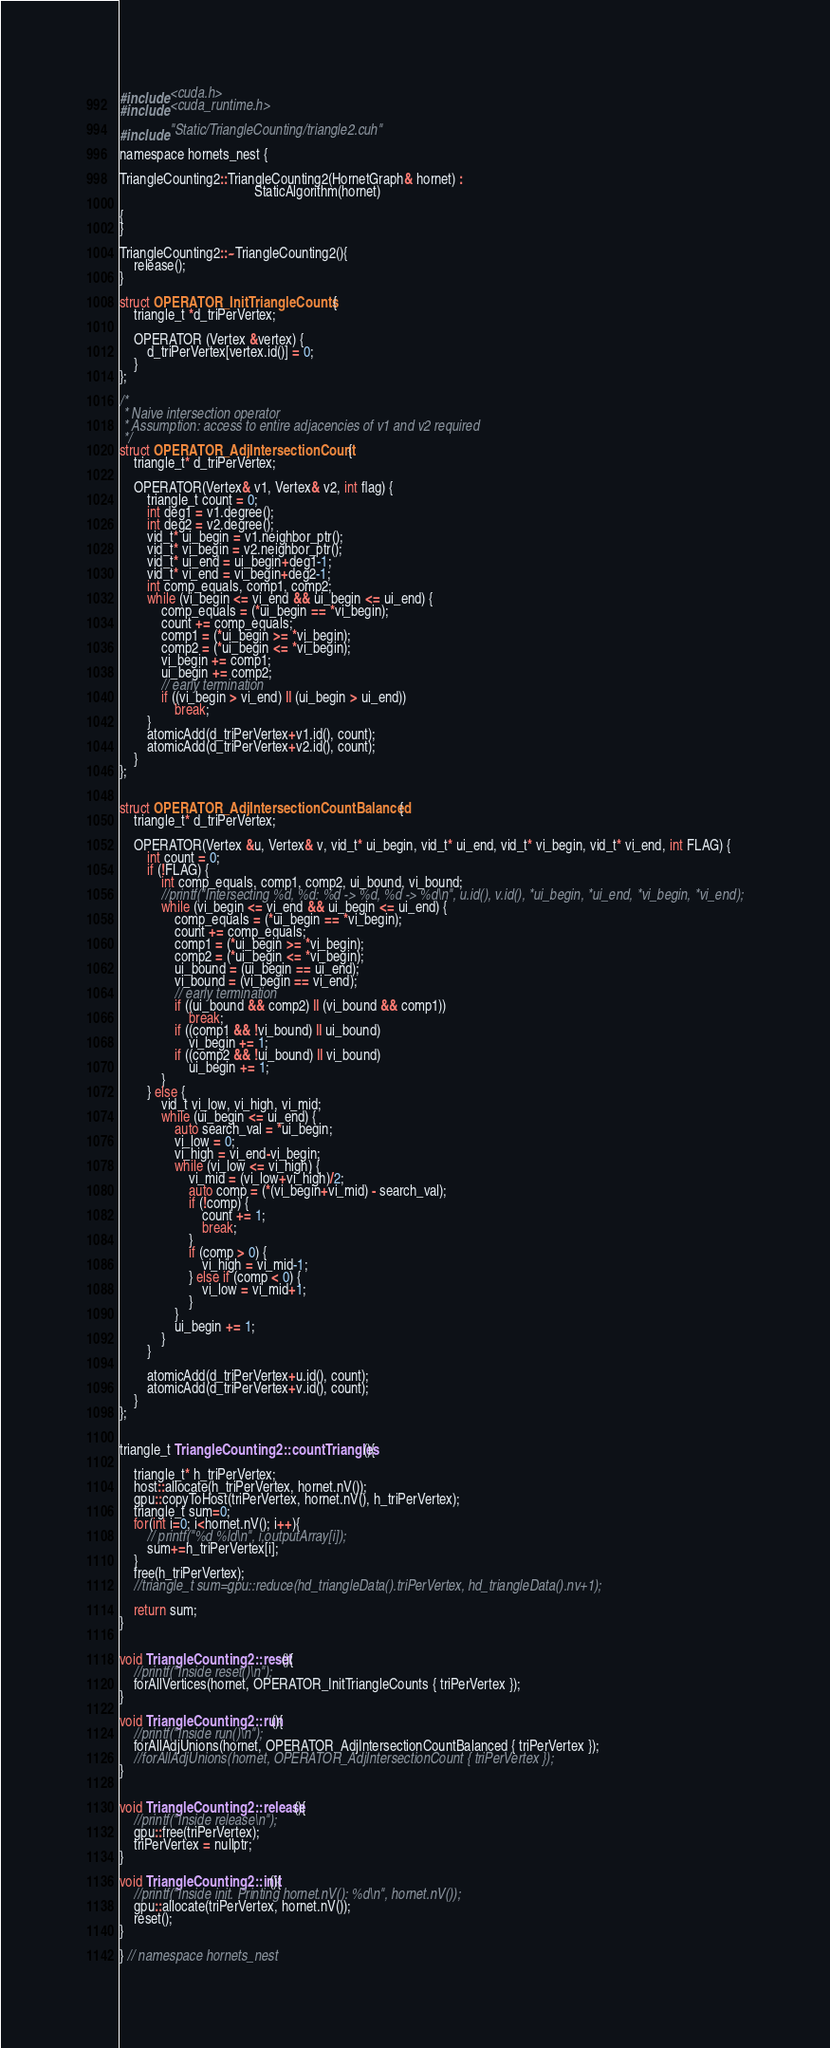Convert code to text. <code><loc_0><loc_0><loc_500><loc_500><_Cuda_>
#include <cuda.h>
#include <cuda_runtime.h>

#include "Static/TriangleCounting/triangle2.cuh"

namespace hornets_nest {

TriangleCounting2::TriangleCounting2(HornetGraph& hornet) :
                                       StaticAlgorithm(hornet)

{                                       
}

TriangleCounting2::~TriangleCounting2(){
    release();
}

struct OPERATOR_InitTriangleCounts {
    triangle_t *d_triPerVertex;

    OPERATOR (Vertex &vertex) {
        d_triPerVertex[vertex.id()] = 0;
    }
};

/*
 * Naive intersection operator
 * Assumption: access to entire adjacencies of v1 and v2 required
 */
struct OPERATOR_AdjIntersectionCount {
    triangle_t* d_triPerVertex;

    OPERATOR(Vertex& v1, Vertex& v2, int flag) {
        triangle_t count = 0;
        int deg1 = v1.degree();
        int deg2 = v2.degree();
        vid_t* ui_begin = v1.neighbor_ptr();
        vid_t* vi_begin = v2.neighbor_ptr();
        vid_t* ui_end = ui_begin+deg1-1;
        vid_t* vi_end = vi_begin+deg2-1;
        int comp_equals, comp1, comp2;
        while (vi_begin <= vi_end && ui_begin <= ui_end) {
            comp_equals = (*ui_begin == *vi_begin);
            count += comp_equals;
            comp1 = (*ui_begin >= *vi_begin);
            comp2 = (*ui_begin <= *vi_begin);
            vi_begin += comp1;
            ui_begin += comp2;
            // early termination
            if ((vi_begin > vi_end) || (ui_begin > ui_end))
                break;
        }
        atomicAdd(d_triPerVertex+v1.id(), count);
        atomicAdd(d_triPerVertex+v2.id(), count);
    }
};


struct OPERATOR_AdjIntersectionCountBalanced {
    triangle_t* d_triPerVertex;

    OPERATOR(Vertex &u, Vertex& v, vid_t* ui_begin, vid_t* ui_end, vid_t* vi_begin, vid_t* vi_end, int FLAG) {
        int count = 0;
        if (!FLAG) {
            int comp_equals, comp1, comp2, ui_bound, vi_bound;
            //printf("Intersecting %d, %d: %d -> %d, %d -> %d\n", u.id(), v.id(), *ui_begin, *ui_end, *vi_begin, *vi_end);
            while (vi_begin <= vi_end && ui_begin <= ui_end) {
                comp_equals = (*ui_begin == *vi_begin);
                count += comp_equals;
                comp1 = (*ui_begin >= *vi_begin);
                comp2 = (*ui_begin <= *vi_begin);
                ui_bound = (ui_begin == ui_end);
                vi_bound = (vi_begin == vi_end);
                // early termination
                if ((ui_bound && comp2) || (vi_bound && comp1))
                    break;
                if ((comp1 && !vi_bound) || ui_bound)
                    vi_begin += 1;
                if ((comp2 && !ui_bound) || vi_bound)
                    ui_begin += 1;
            }
        } else {
            vid_t vi_low, vi_high, vi_mid;
            while (ui_begin <= ui_end) {
                auto search_val = *ui_begin;
                vi_low = 0;
                vi_high = vi_end-vi_begin;
                while (vi_low <= vi_high) {
                    vi_mid = (vi_low+vi_high)/2;
                    auto comp = (*(vi_begin+vi_mid) - search_val);
                    if (!comp) {
                        count += 1;
                        break;
                    }
                    if (comp > 0) {
                        vi_high = vi_mid-1;
                    } else if (comp < 0) {
                        vi_low = vi_mid+1;
                    }
                }
                ui_begin += 1;
            }
        }

        atomicAdd(d_triPerVertex+u.id(), count);
        atomicAdd(d_triPerVertex+v.id(), count);
    }
};


triangle_t TriangleCounting2::countTriangles(){

    triangle_t* h_triPerVertex;
    host::allocate(h_triPerVertex, hornet.nV());
    gpu::copyToHost(triPerVertex, hornet.nV(), h_triPerVertex);
    triangle_t sum=0;
    for(int i=0; i<hornet.nV(); i++){
        // printf("%d %ld\n", i,outputArray[i]);
        sum+=h_triPerVertex[i];
    }
    free(h_triPerVertex);
    //triangle_t sum=gpu::reduce(hd_triangleData().triPerVertex, hd_triangleData().nv+1);

    return sum;
}


void TriangleCounting2::reset(){
    //printf("Inside reset()\n");
    forAllVertices(hornet, OPERATOR_InitTriangleCounts { triPerVertex });
}

void TriangleCounting2::run(){
    //printf("Inside run()\n");
    forAllAdjUnions(hornet, OPERATOR_AdjIntersectionCountBalanced { triPerVertex });
    //forAllAdjUnions(hornet, OPERATOR_AdjIntersectionCount { triPerVertex });
}


void TriangleCounting2::release(){
    //printf("Inside release\n");
    gpu::free(triPerVertex);
    triPerVertex = nullptr;
}

void TriangleCounting2::init(){
    //printf("Inside init. Printing hornet.nV(): %d\n", hornet.nV());
    gpu::allocate(triPerVertex, hornet.nV());
    reset();
}

} // namespace hornets_nest
</code> 